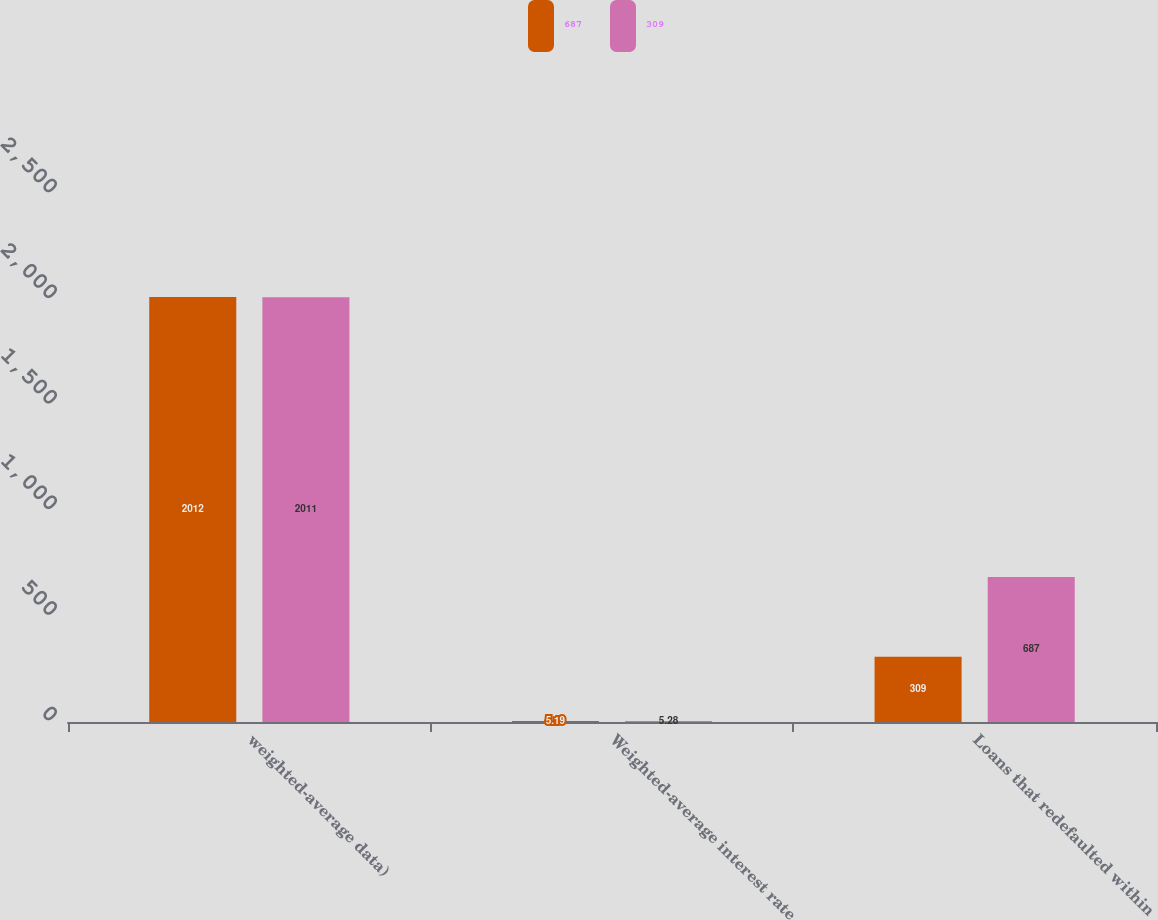<chart> <loc_0><loc_0><loc_500><loc_500><stacked_bar_chart><ecel><fcel>weighted-average data)<fcel>Weighted-average interest rate<fcel>Loans that redefaulted within<nl><fcel>687<fcel>2012<fcel>5.19<fcel>309<nl><fcel>309<fcel>2011<fcel>5.28<fcel>687<nl></chart> 